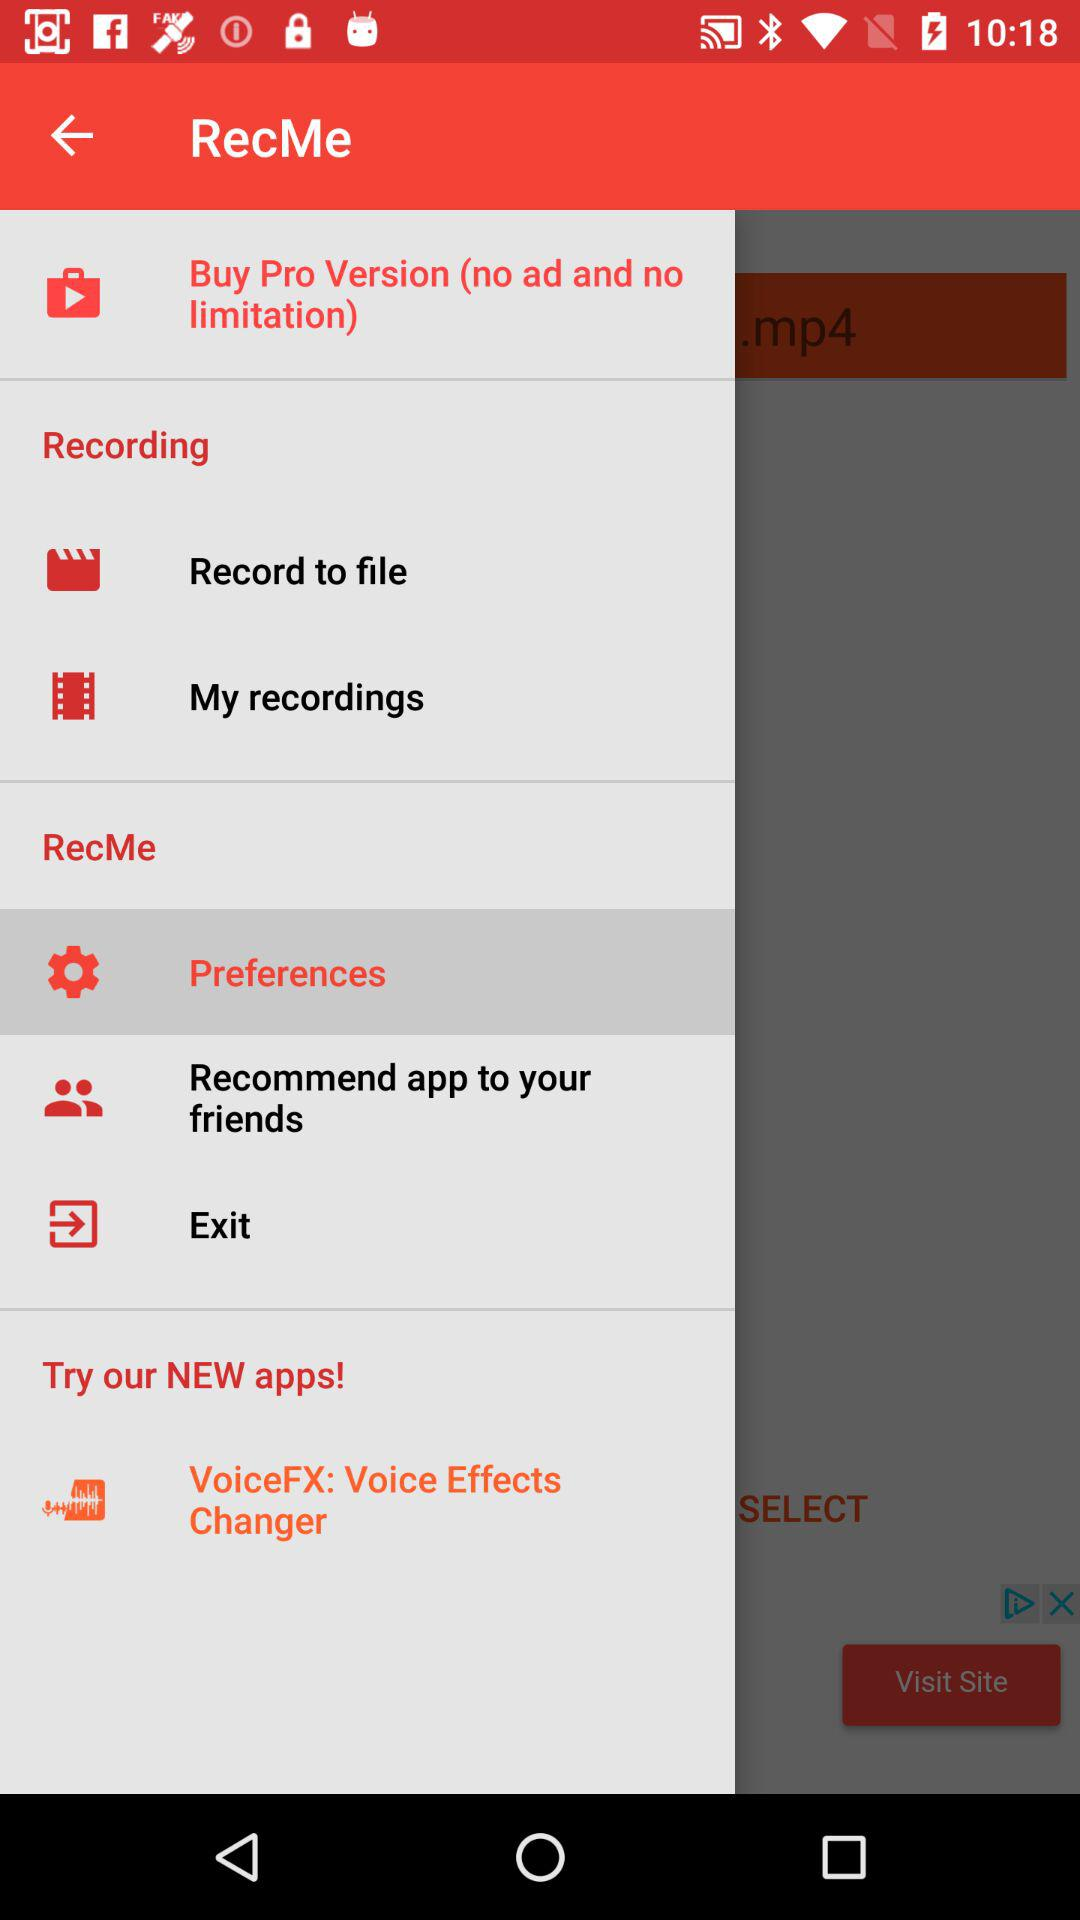What is the name of the new application? The name of the new application is "VoiceFX: Voice Effects Changer". 